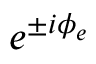Convert formula to latex. <formula><loc_0><loc_0><loc_500><loc_500>e ^ { \pm i \phi _ { e } }</formula> 